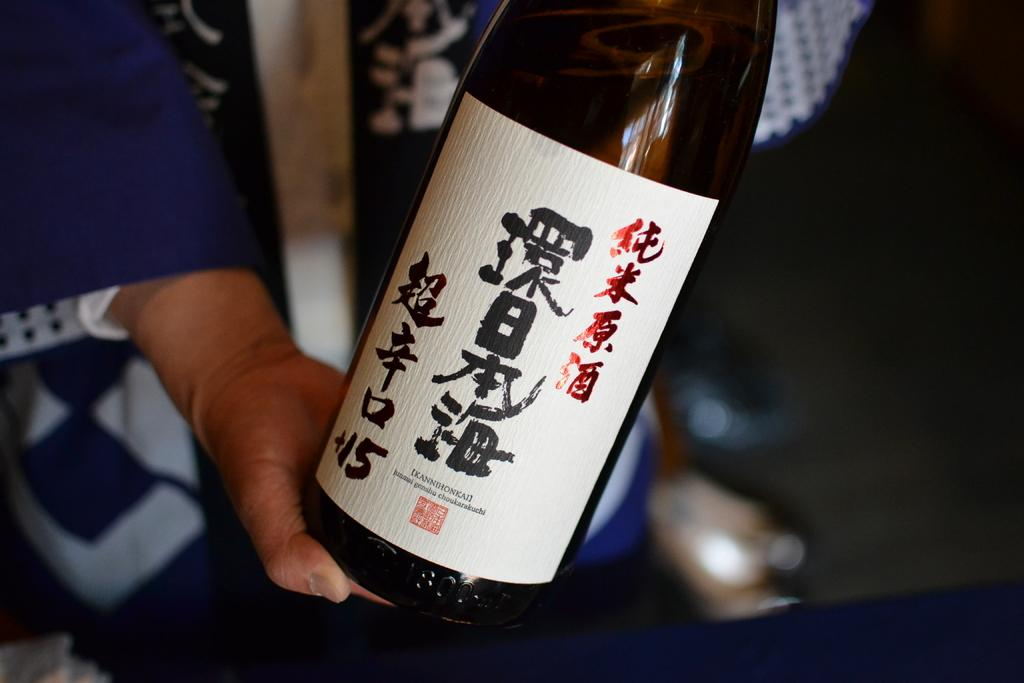What is present in the image? There is a person in the image. What is the person holding in his hand? The person is holding a bottle in his hand. What type of quiver is the person using to sort the expansion in the image? There is no quiver, sorting, or expansion present in the image; it only features a person holding a bottle. 